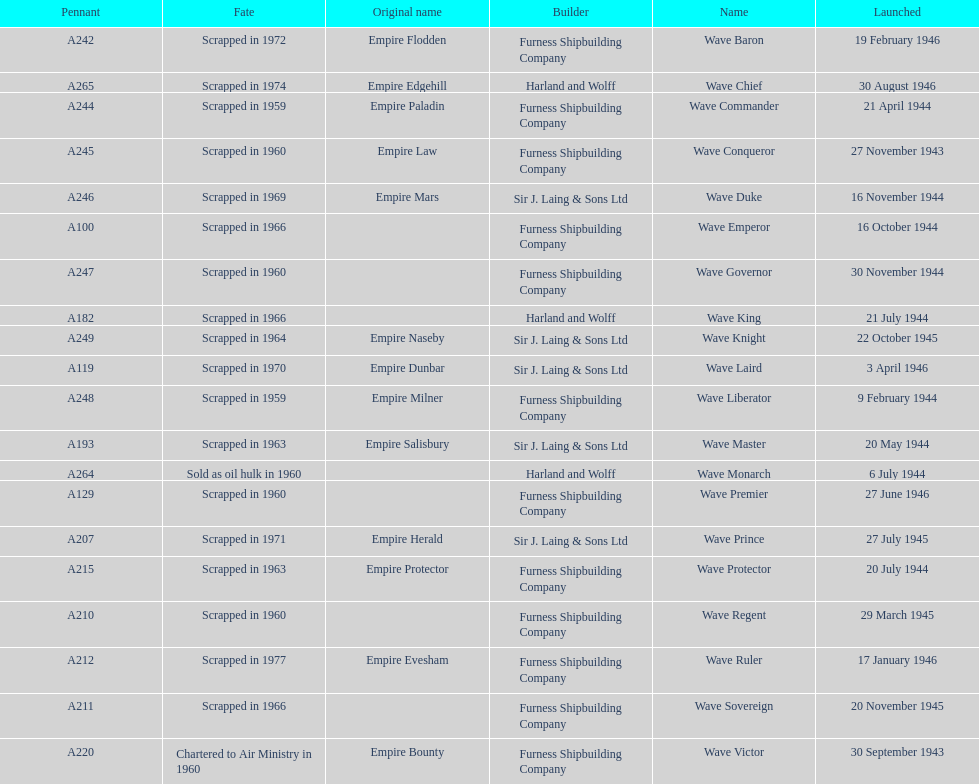Name a builder with "and" in the name. Harland and Wolff. 